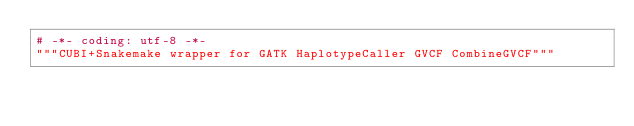<code> <loc_0><loc_0><loc_500><loc_500><_Python_># -*- coding: utf-8 -*-
"""CUBI+Snakemake wrapper for GATK HaplotypeCaller GVCF CombineGVCF"""
</code> 